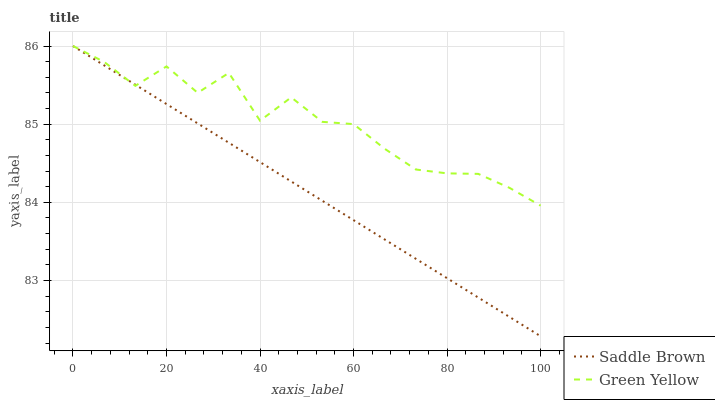Does Saddle Brown have the minimum area under the curve?
Answer yes or no. Yes. Does Green Yellow have the maximum area under the curve?
Answer yes or no. Yes. Does Saddle Brown have the maximum area under the curve?
Answer yes or no. No. Is Saddle Brown the smoothest?
Answer yes or no. Yes. Is Green Yellow the roughest?
Answer yes or no. Yes. Is Saddle Brown the roughest?
Answer yes or no. No. Does Saddle Brown have the lowest value?
Answer yes or no. Yes. Does Saddle Brown have the highest value?
Answer yes or no. Yes. Does Green Yellow intersect Saddle Brown?
Answer yes or no. Yes. Is Green Yellow less than Saddle Brown?
Answer yes or no. No. Is Green Yellow greater than Saddle Brown?
Answer yes or no. No. 